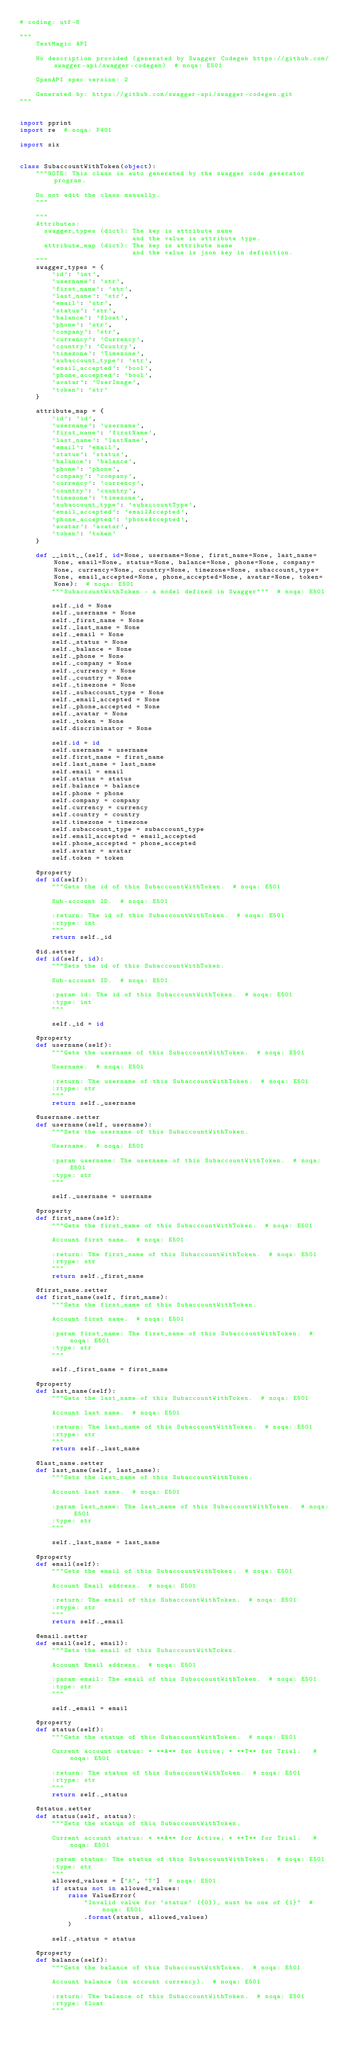Convert code to text. <code><loc_0><loc_0><loc_500><loc_500><_Python_># coding: utf-8

"""
    TextMagic API

    No description provided (generated by Swagger Codegen https://github.com/swagger-api/swagger-codegen)  # noqa: E501

    OpenAPI spec version: 2
    
    Generated by: https://github.com/swagger-api/swagger-codegen.git
"""


import pprint
import re  # noqa: F401

import six


class SubaccountWithToken(object):
    """NOTE: This class is auto generated by the swagger code generator program.

    Do not edit the class manually.
    """

    """
    Attributes:
      swagger_types (dict): The key is attribute name
                            and the value is attribute type.
      attribute_map (dict): The key is attribute name
                            and the value is json key in definition.
    """
    swagger_types = {
        'id': 'int',
        'username': 'str',
        'first_name': 'str',
        'last_name': 'str',
        'email': 'str',
        'status': 'str',
        'balance': 'float',
        'phone': 'str',
        'company': 'str',
        'currency': 'Currency',
        'country': 'Country',
        'timezone': 'Timezone',
        'subaccount_type': 'str',
        'email_accepted': 'bool',
        'phone_accepted': 'bool',
        'avatar': 'UserImage',
        'token': 'str'
    }

    attribute_map = {
        'id': 'id',
        'username': 'username',
        'first_name': 'firstName',
        'last_name': 'lastName',
        'email': 'email',
        'status': 'status',
        'balance': 'balance',
        'phone': 'phone',
        'company': 'company',
        'currency': 'currency',
        'country': 'country',
        'timezone': 'timezone',
        'subaccount_type': 'subaccountType',
        'email_accepted': 'emailAccepted',
        'phone_accepted': 'phoneAccepted',
        'avatar': 'avatar',
        'token': 'token'
    }

    def __init__(self, id=None, username=None, first_name=None, last_name=None, email=None, status=None, balance=None, phone=None, company=None, currency=None, country=None, timezone=None, subaccount_type=None, email_accepted=None, phone_accepted=None, avatar=None, token=None):  # noqa: E501
        """SubaccountWithToken - a model defined in Swagger"""  # noqa: E501

        self._id = None
        self._username = None
        self._first_name = None
        self._last_name = None
        self._email = None
        self._status = None
        self._balance = None
        self._phone = None
        self._company = None
        self._currency = None
        self._country = None
        self._timezone = None
        self._subaccount_type = None
        self._email_accepted = None
        self._phone_accepted = None
        self._avatar = None
        self._token = None
        self.discriminator = None

        self.id = id
        self.username = username
        self.first_name = first_name
        self.last_name = last_name
        self.email = email
        self.status = status
        self.balance = balance
        self.phone = phone
        self.company = company
        self.currency = currency
        self.country = country
        self.timezone = timezone
        self.subaccount_type = subaccount_type
        self.email_accepted = email_accepted
        self.phone_accepted = phone_accepted
        self.avatar = avatar
        self.token = token

    @property
    def id(self):
        """Gets the id of this SubaccountWithToken.  # noqa: E501

        Sub-account ID.  # noqa: E501

        :return: The id of this SubaccountWithToken.  # noqa: E501
        :rtype: int
        """
        return self._id

    @id.setter
    def id(self, id):
        """Sets the id of this SubaccountWithToken.

        Sub-account ID.  # noqa: E501

        :param id: The id of this SubaccountWithToken.  # noqa: E501
        :type: int
        """

        self._id = id

    @property
    def username(self):
        """Gets the username of this SubaccountWithToken.  # noqa: E501

        Username.  # noqa: E501

        :return: The username of this SubaccountWithToken.  # noqa: E501
        :rtype: str
        """
        return self._username

    @username.setter
    def username(self, username):
        """Sets the username of this SubaccountWithToken.

        Username.  # noqa: E501

        :param username: The username of this SubaccountWithToken.  # noqa: E501
        :type: str
        """

        self._username = username

    @property
    def first_name(self):
        """Gets the first_name of this SubaccountWithToken.  # noqa: E501

        Account first name.  # noqa: E501

        :return: The first_name of this SubaccountWithToken.  # noqa: E501
        :rtype: str
        """
        return self._first_name

    @first_name.setter
    def first_name(self, first_name):
        """Sets the first_name of this SubaccountWithToken.

        Account first name.  # noqa: E501

        :param first_name: The first_name of this SubaccountWithToken.  # noqa: E501
        :type: str
        """

        self._first_name = first_name

    @property
    def last_name(self):
        """Gets the last_name of this SubaccountWithToken.  # noqa: E501

        Account last name.  # noqa: E501

        :return: The last_name of this SubaccountWithToken.  # noqa: E501
        :rtype: str
        """
        return self._last_name

    @last_name.setter
    def last_name(self, last_name):
        """Sets the last_name of this SubaccountWithToken.

        Account last name.  # noqa: E501

        :param last_name: The last_name of this SubaccountWithToken.  # noqa: E501
        :type: str
        """

        self._last_name = last_name

    @property
    def email(self):
        """Gets the email of this SubaccountWithToken.  # noqa: E501

        Account Email address.  # noqa: E501

        :return: The email of this SubaccountWithToken.  # noqa: E501
        :rtype: str
        """
        return self._email

    @email.setter
    def email(self, email):
        """Sets the email of this SubaccountWithToken.

        Account Email address.  # noqa: E501

        :param email: The email of this SubaccountWithToken.  # noqa: E501
        :type: str
        """

        self._email = email

    @property
    def status(self):
        """Gets the status of this SubaccountWithToken.  # noqa: E501

        Current account status: * **A** for Active; * **T** for Trial.   # noqa: E501

        :return: The status of this SubaccountWithToken.  # noqa: E501
        :rtype: str
        """
        return self._status

    @status.setter
    def status(self, status):
        """Sets the status of this SubaccountWithToken.

        Current account status: * **A** for Active; * **T** for Trial.   # noqa: E501

        :param status: The status of this SubaccountWithToken.  # noqa: E501
        :type: str
        """
        allowed_values = ["A", "T"]  # noqa: E501
        if status not in allowed_values:
            raise ValueError(
                "Invalid value for `status` ({0}), must be one of {1}"  # noqa: E501
                .format(status, allowed_values)
            )

        self._status = status

    @property
    def balance(self):
        """Gets the balance of this SubaccountWithToken.  # noqa: E501

        Account balance (in account currency).  # noqa: E501

        :return: The balance of this SubaccountWithToken.  # noqa: E501
        :rtype: float
        """</code> 